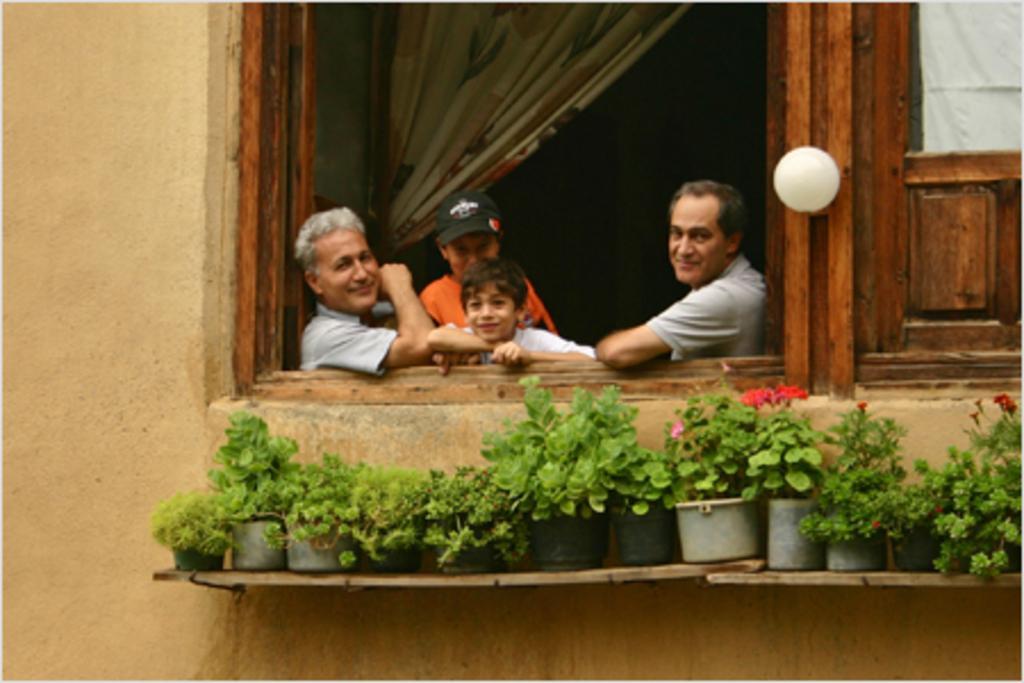Describe this image in one or two sentences. In this picture we can see a few flower pots on the wooden objects. We can see a few people smiling in the building. There is a window, curtain and a few wooden objects are visible on the building. 